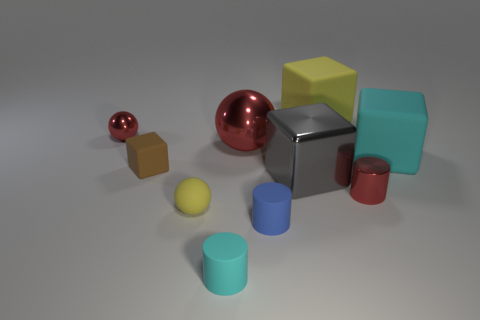Does the shiny cylinder have the same color as the tiny metallic ball?
Provide a succinct answer. Yes. Are any big green objects visible?
Provide a succinct answer. No. There is a big yellow object that is the same shape as the large cyan object; what material is it?
Your answer should be compact. Rubber. Are there any yellow matte objects right of the small yellow matte thing?
Ensure brevity in your answer.  Yes. Are the small red thing that is behind the big gray metal thing and the tiny yellow object made of the same material?
Offer a very short reply. No. Are there any tiny metal cylinders of the same color as the big ball?
Offer a terse response. Yes. What is the shape of the small cyan object?
Ensure brevity in your answer.  Cylinder. There is a thing that is behind the small red thing that is behind the big cyan object; what is its color?
Provide a succinct answer. Yellow. How big is the cyan rubber thing that is behind the tiny blue matte object?
Your answer should be very brief. Large. Is there a big cube that has the same material as the big gray object?
Make the answer very short. No. 